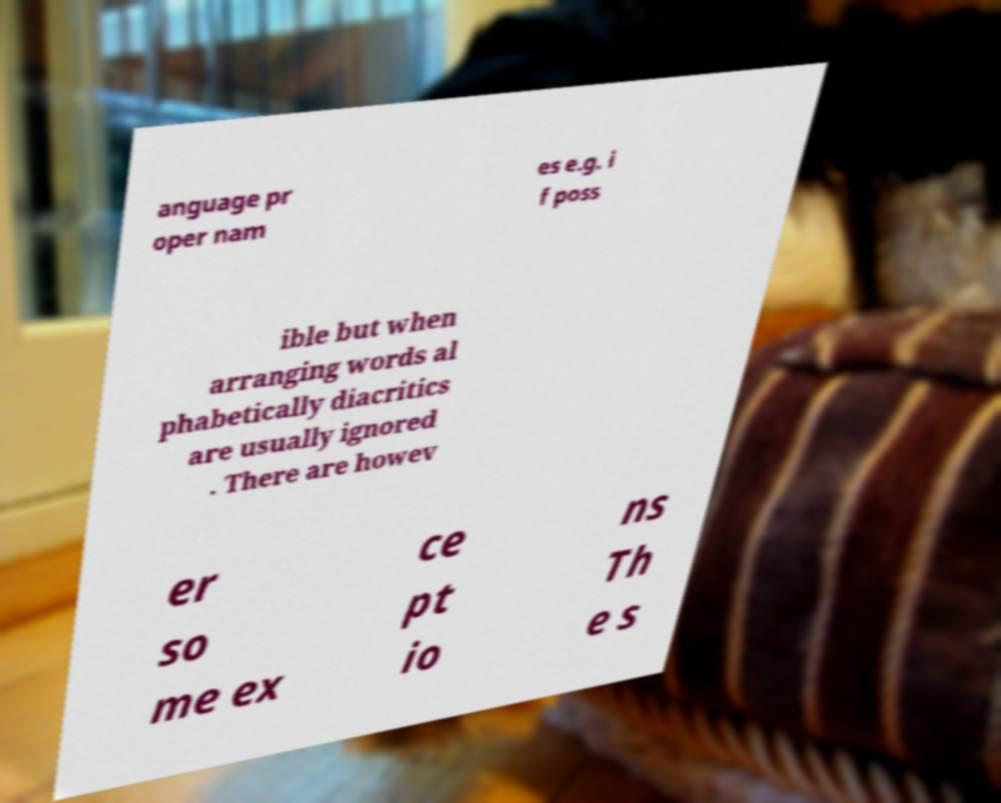Please read and relay the text visible in this image. What does it say? anguage pr oper nam es e.g. i f poss ible but when arranging words al phabetically diacritics are usually ignored . There are howev er so me ex ce pt io ns Th e s 